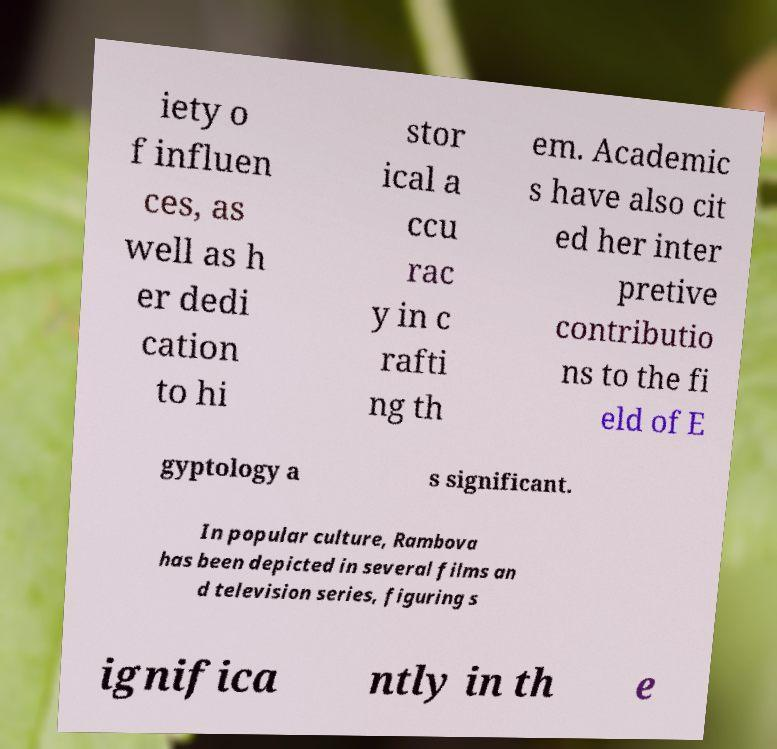There's text embedded in this image that I need extracted. Can you transcribe it verbatim? iety o f influen ces, as well as h er dedi cation to hi stor ical a ccu rac y in c rafti ng th em. Academic s have also cit ed her inter pretive contributio ns to the fi eld of E gyptology a s significant. In popular culture, Rambova has been depicted in several films an d television series, figuring s ignifica ntly in th e 